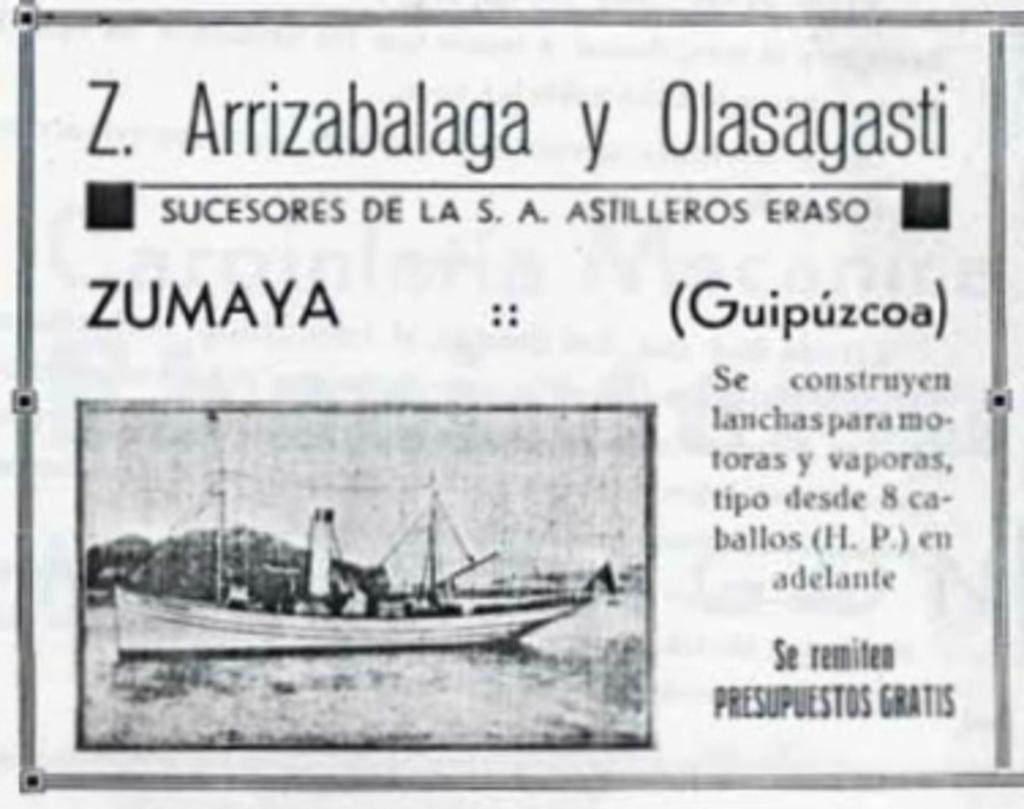What is the main subject of the black and white picture in the image? The main subject of the black and white picture in the image is a ship. Where is the ship located in the image? The ship is in a water body in the image. What else can be seen on the image besides the ship? There is text present on the image. Can you tell me how many horses are visible in the image? There are no horses present in the image; it features a black and white picture of a ship. Is there any indication of rain in the image? There is no mention or depiction of rain in the image. 